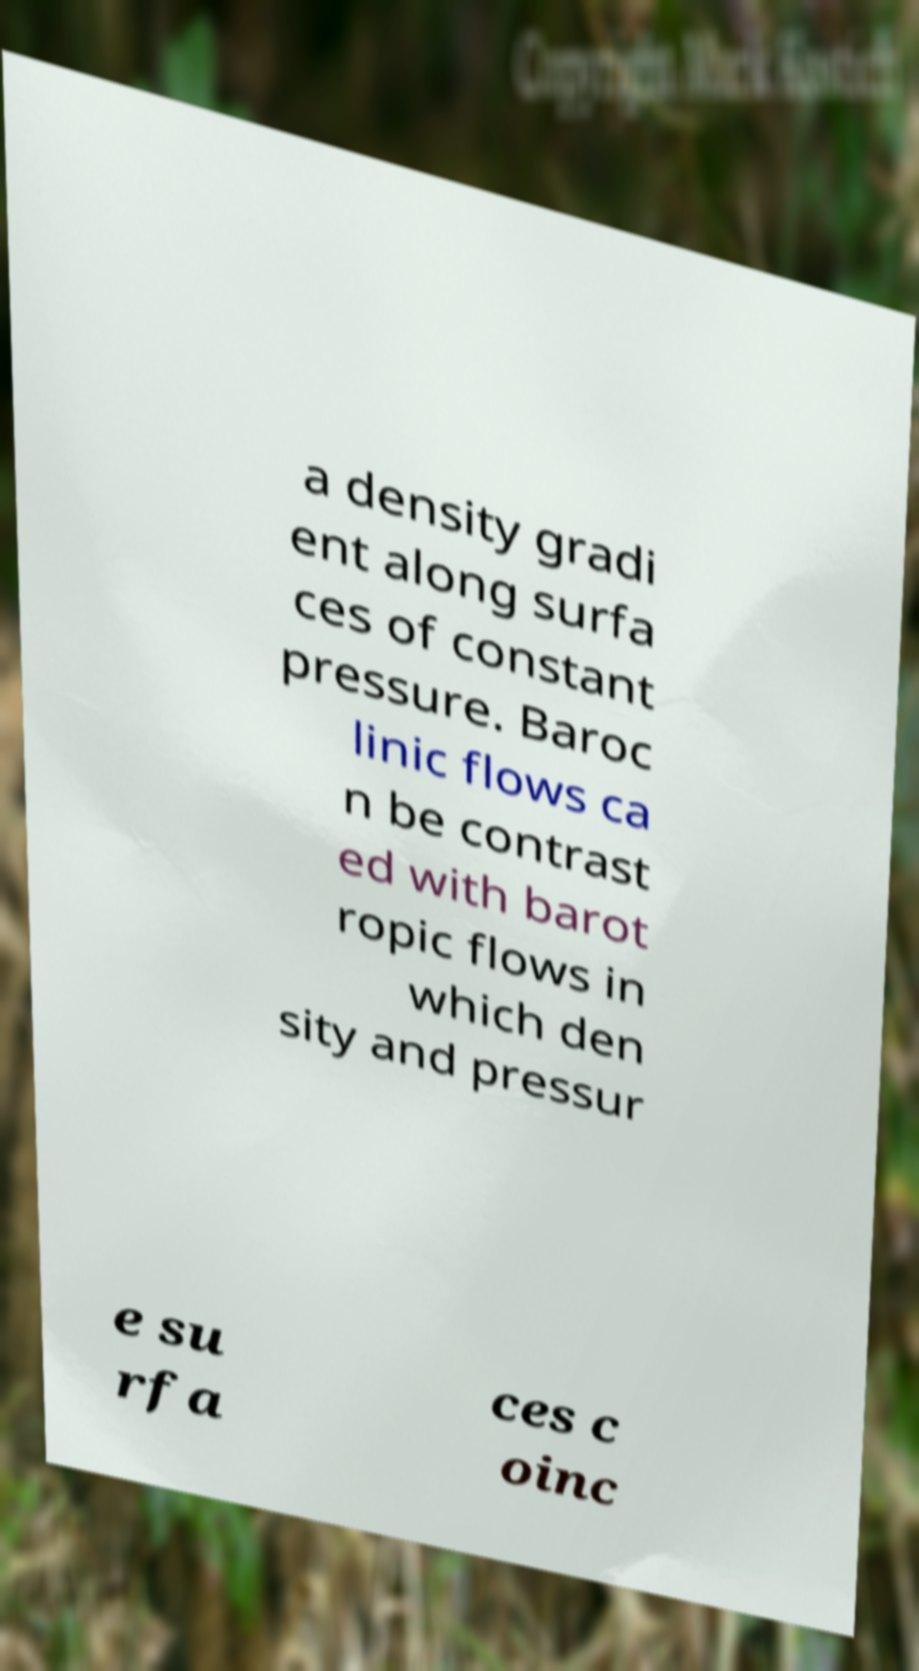Please read and relay the text visible in this image. What does it say? a density gradi ent along surfa ces of constant pressure. Baroc linic flows ca n be contrast ed with barot ropic flows in which den sity and pressur e su rfa ces c oinc 